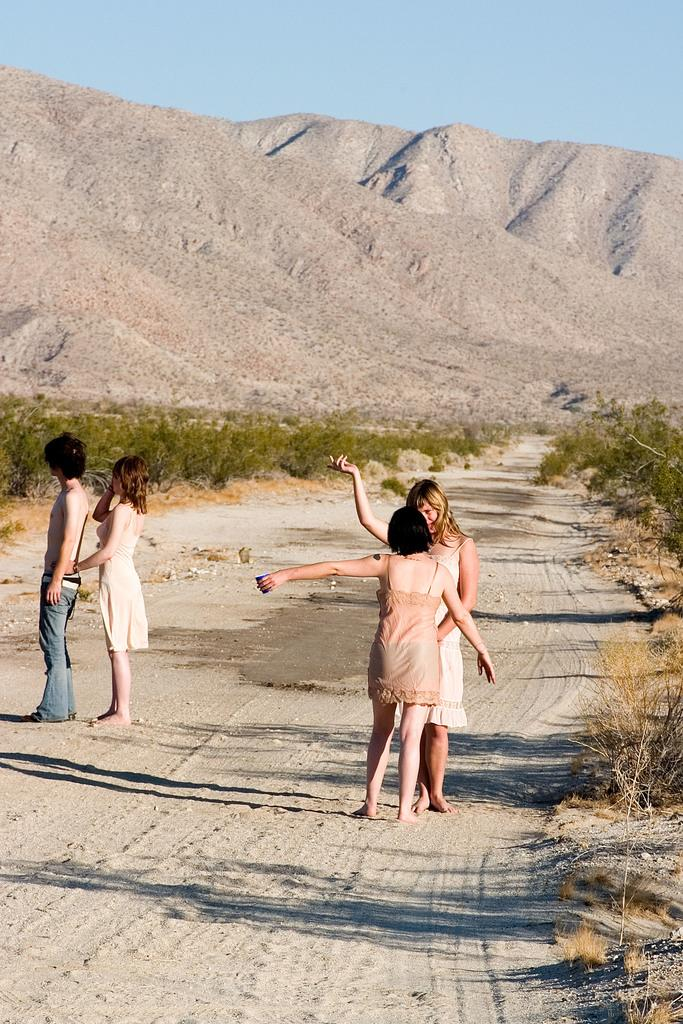What are the people in the image doing? The people in the image are standing on the road. What can be seen in the background of the image? There are plants visible in the image. What type of natural feature is present in the image? There are sand hills in the image. What type of steam can be seen coming from the plants in the image? There is no steam visible in the image; only plants are present. 